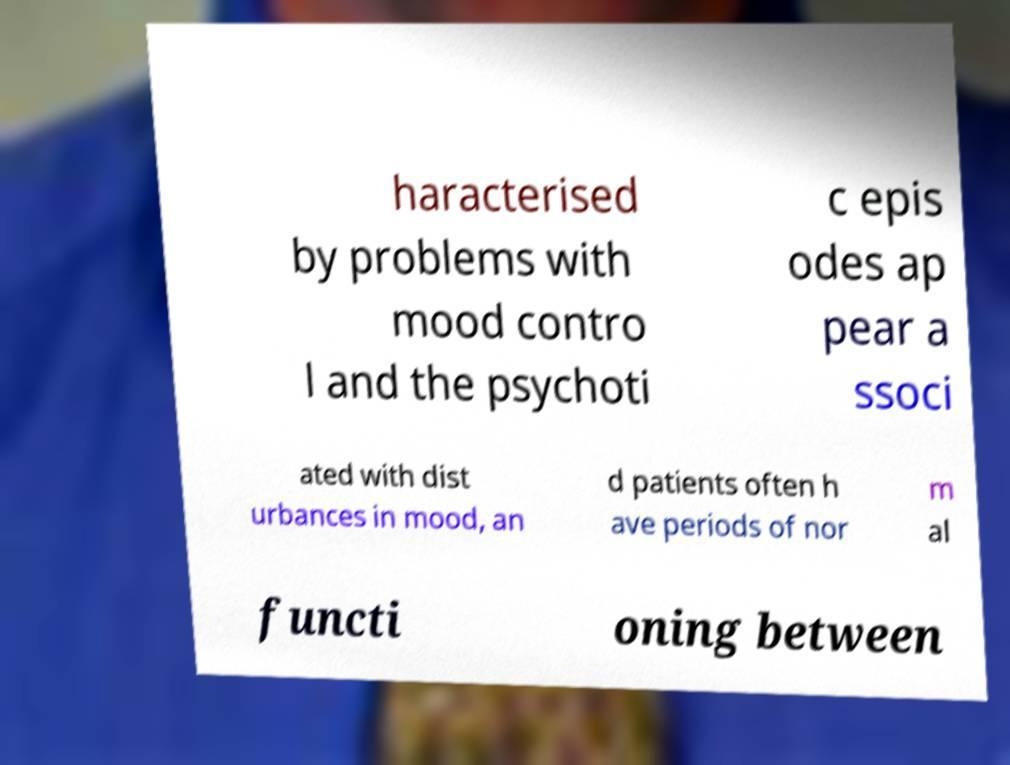What messages or text are displayed in this image? I need them in a readable, typed format. haracterised by problems with mood contro l and the psychoti c epis odes ap pear a ssoci ated with dist urbances in mood, an d patients often h ave periods of nor m al functi oning between 